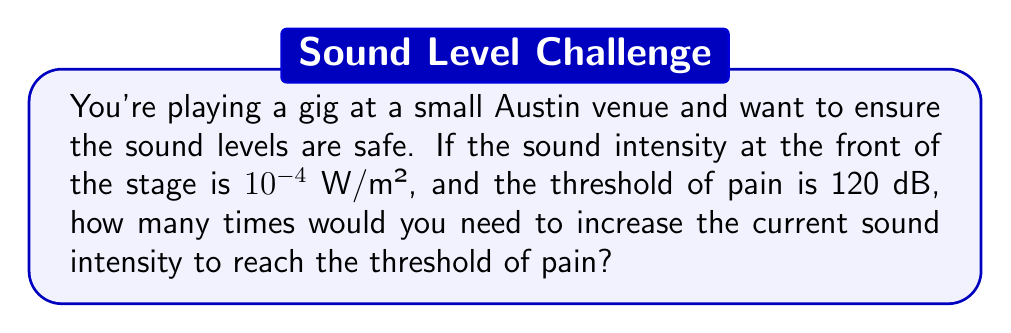Could you help me with this problem? Let's approach this step-by-step:

1) The formula for sound intensity level in decibels is:

   $$ \text{dB} = 10 \log_{10}\left(\frac{I}{I_0}\right) $$

   where $I$ is the sound intensity and $I_0$ is the reference intensity ($10^{-12}$ W/m²).

2) We're given that the current intensity $I_1 = 10^{-4}$ W/m². Let's calculate its dB level:

   $$ \text{dB}_1 = 10 \log_{10}\left(\frac{10^{-4}}{10^{-12}}\right) = 10 \log_{10}(10^8) = 10 \cdot 8 = 80 \text{ dB} $$

3) The threshold of pain is given as 120 dB. We need to find the intensity $I_2$ that corresponds to this:

   $$ 120 = 10 \log_{10}\left(\frac{I_2}{10^{-12}}\right) $$

4) Solving for $I_2$:

   $$ 12 = \log_{10}\left(\frac{I_2}{10^{-12}}\right) $$
   $$ 10^{12} = \frac{I_2}{10^{-12}} $$
   $$ I_2 = 10^{12} \cdot 10^{-12} = 1 \text{ W/m²} $$

5) To find how many times we need to increase the current intensity, we divide $I_2$ by $I_1$:

   $$ \frac{I_2}{I_1} = \frac{1}{10^{-4}} = 10^4 = 10,000 $$

Therefore, you would need to increase the current sound intensity 10,000 times to reach the threshold of pain.
Answer: 10,000 times 